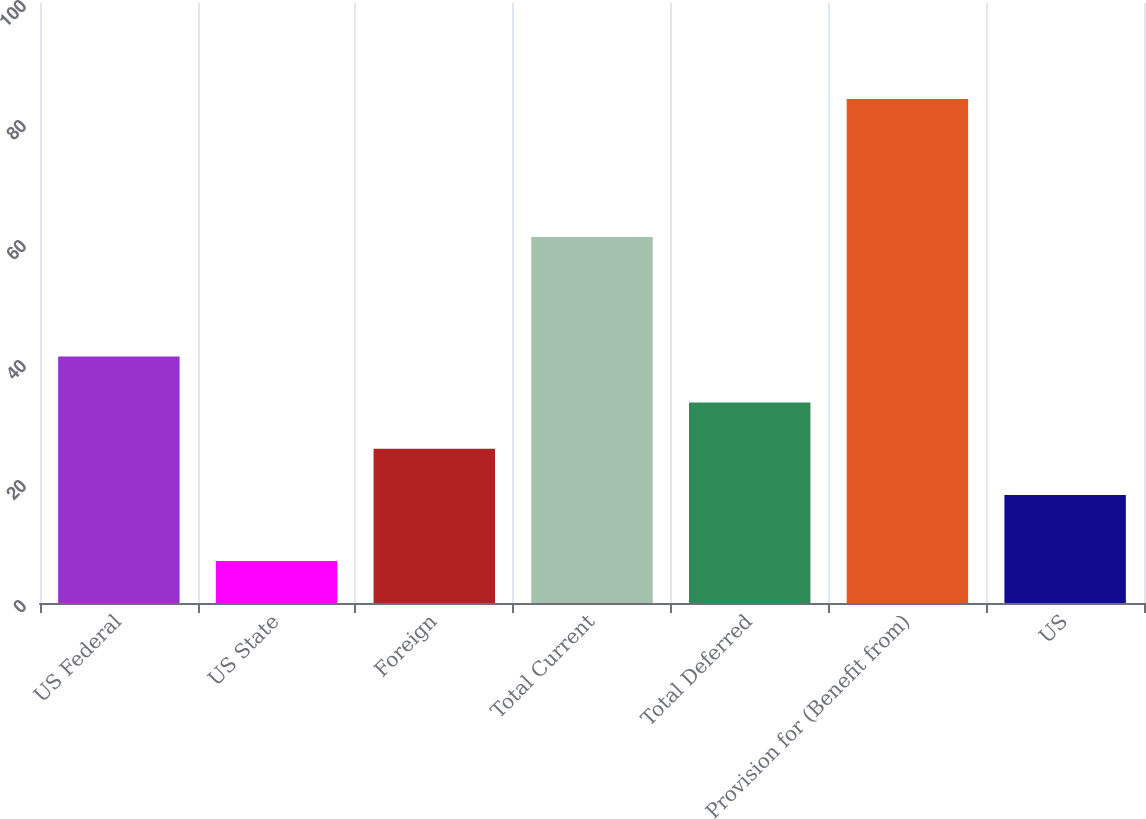Convert chart. <chart><loc_0><loc_0><loc_500><loc_500><bar_chart><fcel>US Federal<fcel>US State<fcel>Foreign<fcel>Total Current<fcel>Total Deferred<fcel>Provision for (Benefit from)<fcel>US<nl><fcel>41.1<fcel>7<fcel>25.7<fcel>61<fcel>33.4<fcel>84<fcel>18<nl></chart> 